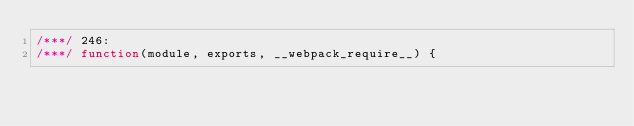Convert code to text. <code><loc_0><loc_0><loc_500><loc_500><_JavaScript_>/***/ 246:
/***/ function(module, exports, __webpack_require__) {
</code> 